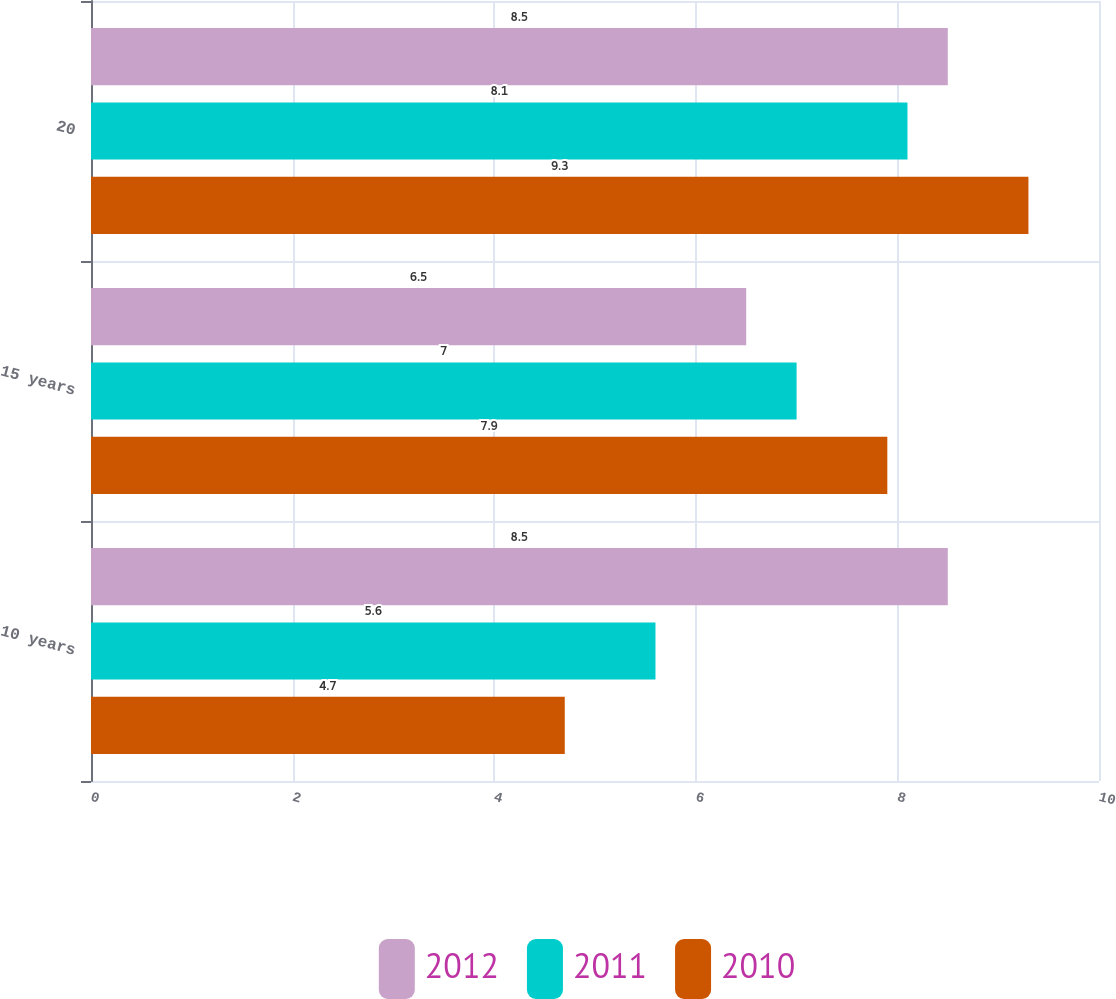Convert chart to OTSL. <chart><loc_0><loc_0><loc_500><loc_500><stacked_bar_chart><ecel><fcel>10 years<fcel>15 years<fcel>20<nl><fcel>2012<fcel>8.5<fcel>6.5<fcel>8.5<nl><fcel>2011<fcel>5.6<fcel>7<fcel>8.1<nl><fcel>2010<fcel>4.7<fcel>7.9<fcel>9.3<nl></chart> 